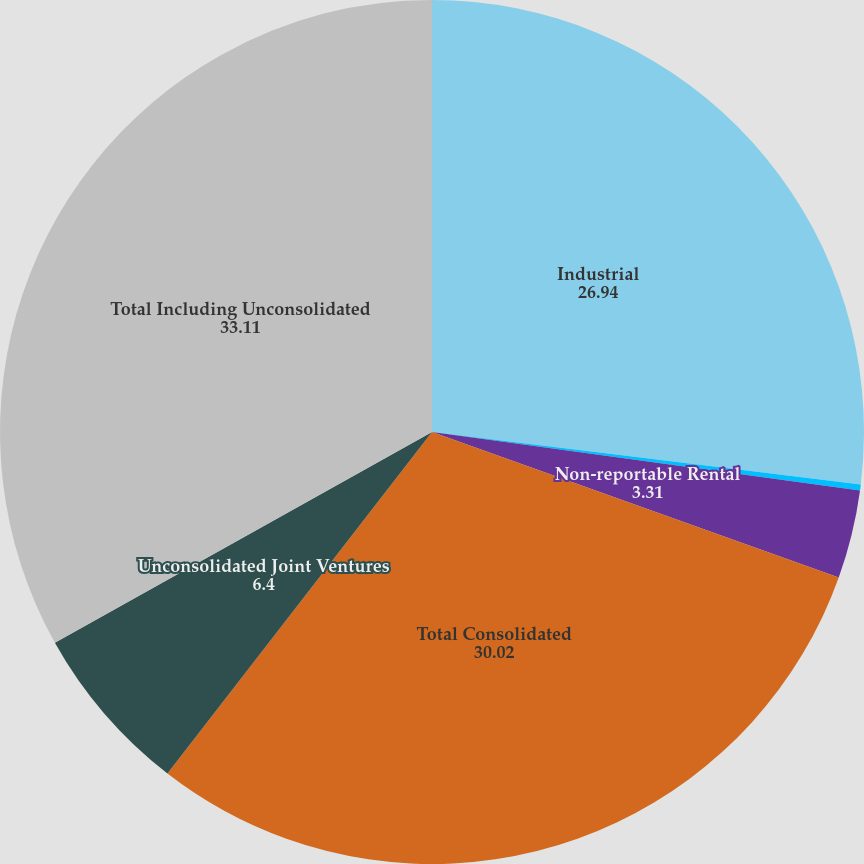Convert chart to OTSL. <chart><loc_0><loc_0><loc_500><loc_500><pie_chart><fcel>Industrial<fcel>Medical Office<fcel>Non-reportable Rental<fcel>Total Consolidated<fcel>Unconsolidated Joint Ventures<fcel>Total Including Unconsolidated<nl><fcel>26.94%<fcel>0.22%<fcel>3.31%<fcel>30.02%<fcel>6.4%<fcel>33.11%<nl></chart> 